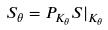<formula> <loc_0><loc_0><loc_500><loc_500>S _ { \theta } = P _ { K _ { \theta } } S | _ { K _ { \theta } }</formula> 